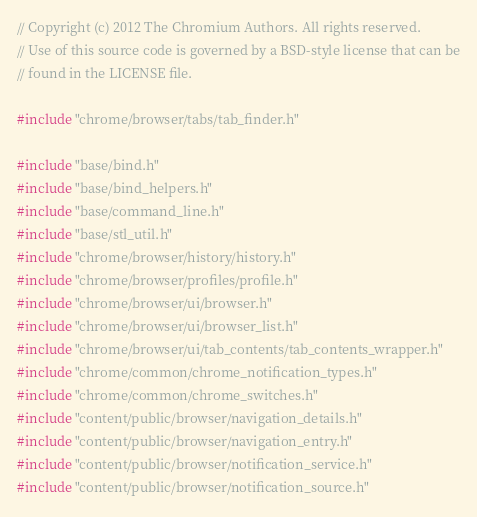<code> <loc_0><loc_0><loc_500><loc_500><_C++_>// Copyright (c) 2012 The Chromium Authors. All rights reserved.
// Use of this source code is governed by a BSD-style license that can be
// found in the LICENSE file.

#include "chrome/browser/tabs/tab_finder.h"

#include "base/bind.h"
#include "base/bind_helpers.h"
#include "base/command_line.h"
#include "base/stl_util.h"
#include "chrome/browser/history/history.h"
#include "chrome/browser/profiles/profile.h"
#include "chrome/browser/ui/browser.h"
#include "chrome/browser/ui/browser_list.h"
#include "chrome/browser/ui/tab_contents/tab_contents_wrapper.h"
#include "chrome/common/chrome_notification_types.h"
#include "chrome/common/chrome_switches.h"
#include "content/public/browser/navigation_details.h"
#include "content/public/browser/navigation_entry.h"
#include "content/public/browser/notification_service.h"
#include "content/public/browser/notification_source.h"</code> 